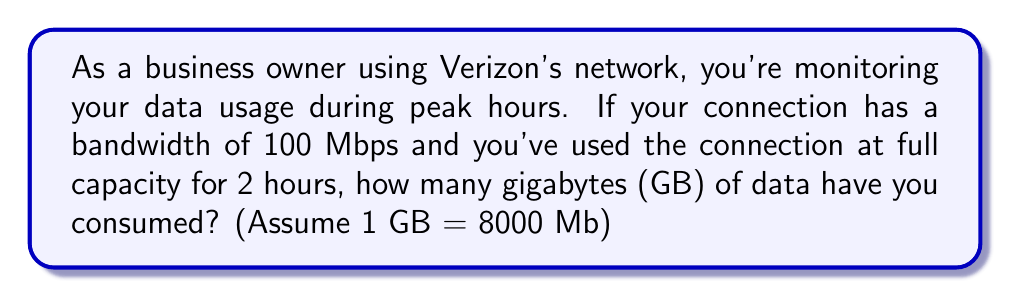Provide a solution to this math problem. Let's approach this step-by-step:

1) First, we need to convert the bandwidth from Mbps (Megabits per second) to Mb per hour:
   $$ 100 \text{ Mbps} \times 3600 \text{ seconds/hour} = 360,000 \text{ Mb/hour} $$

2) Now, we calculate the total data used in Mb for 2 hours:
   $$ 360,000 \text{ Mb/hour} \times 2 \text{ hours} = 720,000 \text{ Mb} $$

3) To convert this to GB, we divide by 8000 (as given in the question):
   $$ \frac{720,000 \text{ Mb}}{8000 \text{ Mb/GB}} = 90 \text{ GB} $$

Therefore, in 2 hours of full capacity usage at 100 Mbps, you would consume 90 GB of data.
Answer: 90 GB 